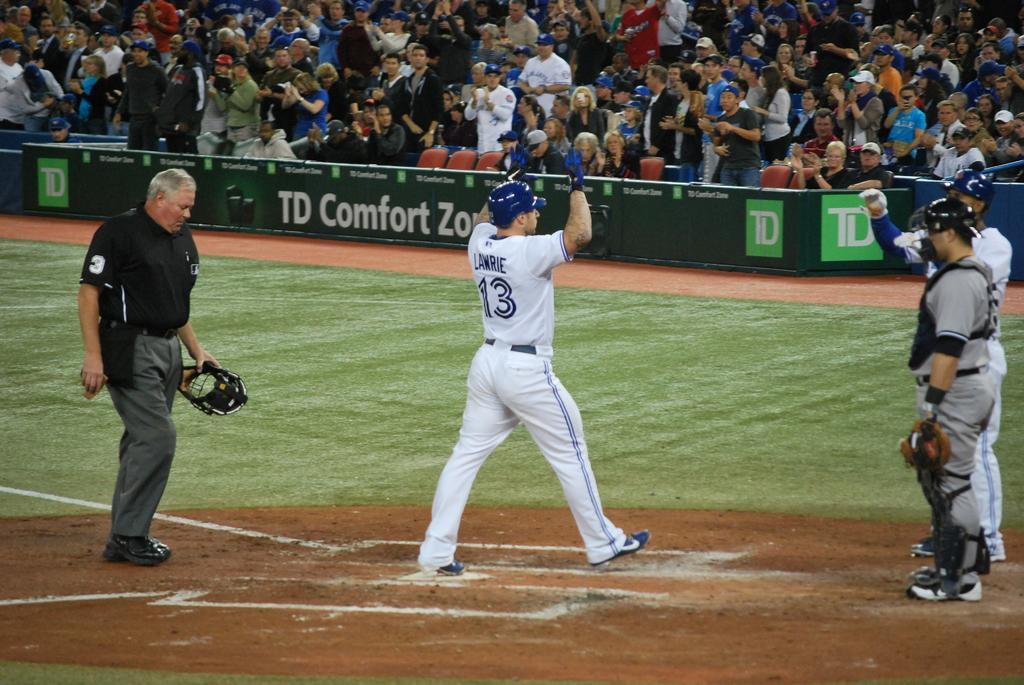<image>
Render a clear and concise summary of the photo. Baseball pitcher Lawrie standing near two other players during a game. 